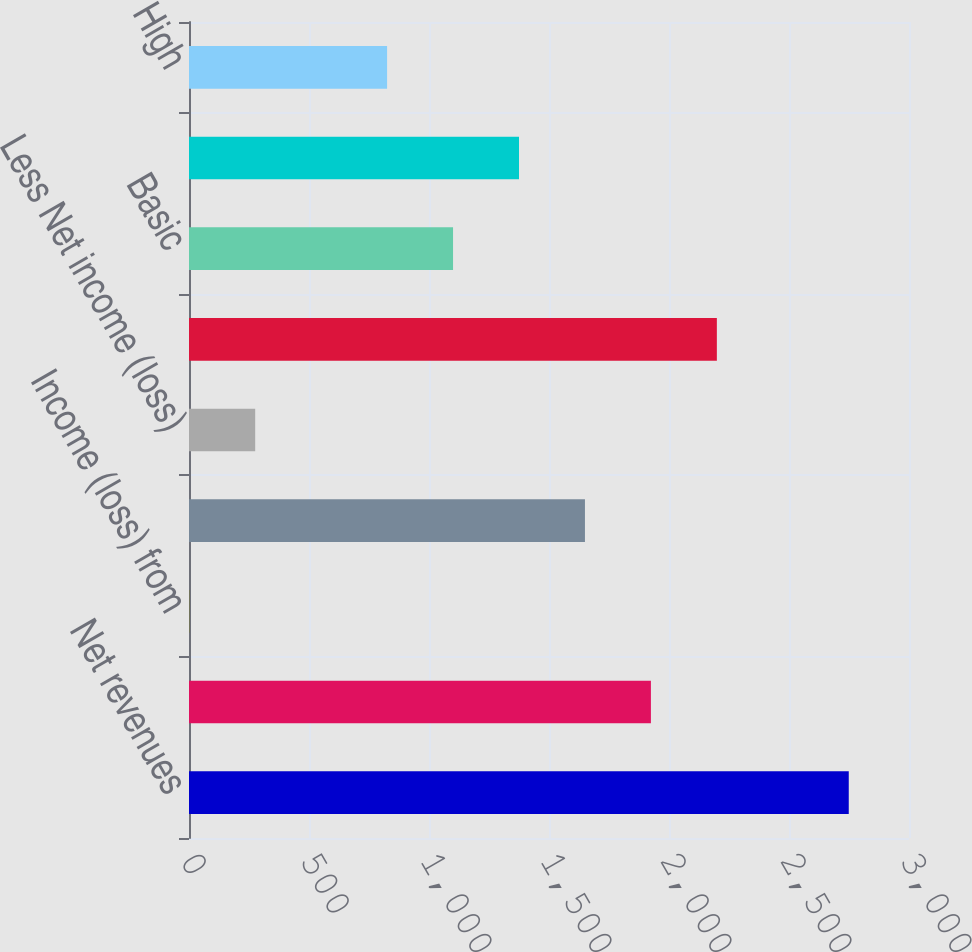Convert chart. <chart><loc_0><loc_0><loc_500><loc_500><bar_chart><fcel>Net revenues<fcel>Income from continuing<fcel>Income (loss) from<fcel>Net income<fcel>Less Net income (loss)<fcel>Net income attributable to<fcel>Basic<fcel>Diluted<fcel>High<nl><fcel>2749<fcel>1924.6<fcel>1<fcel>1649.8<fcel>275.8<fcel>2199.4<fcel>1100.2<fcel>1375<fcel>825.4<nl></chart> 